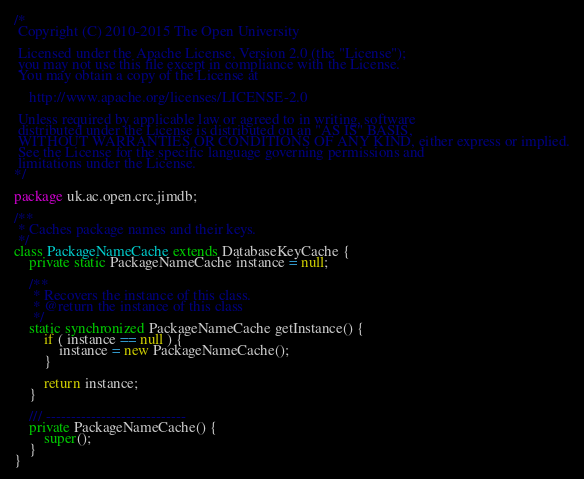Convert code to text. <code><loc_0><loc_0><loc_500><loc_500><_Java_>/*
 Copyright (C) 2010-2015 The Open University

 Licensed under the Apache License, Version 2.0 (the "License");
 you may not use this file except in compliance with the License.
 You may obtain a copy of the License at

    http://www.apache.org/licenses/LICENSE-2.0

 Unless required by applicable law or agreed to in writing, software
 distributed under the License is distributed on an "AS IS" BASIS,
 WITHOUT WARRANTIES OR CONDITIONS OF ANY KIND, either express or implied.
 See the License for the specific language governing permissions and
 limitations under the License.
*/

package uk.ac.open.crc.jimdb;

/**
 * Caches package names and their keys.
 */
class PackageNameCache extends DatabaseKeyCache {
    private static PackageNameCache instance = null;
    
    /**
     * Recovers the instance of this class.
     * @return the instance of this class
     */
    static synchronized PackageNameCache getInstance() {
        if ( instance == null ) {
            instance = new PackageNameCache();
        }
        
        return instance;
    }
    
    /// ----------------------------
    private PackageNameCache() {
        super();
    }
}
</code> 